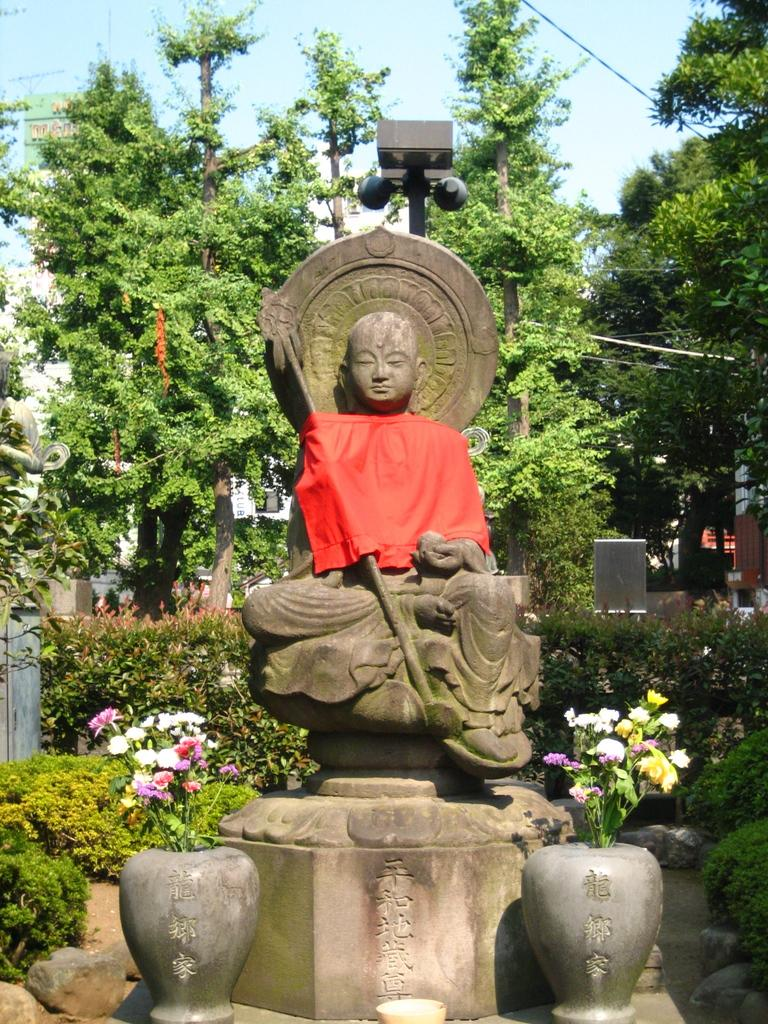What objects are in front of the statue in the image? There are flower vases in front of the statue in the image. What can be seen in the background of the image? There are plants and trees in the background of the image. What is visible at the top of the image? The sky is visible at the top of the image. Can you see the bird flying in the image? There is no bird visible in the image. What type of self-portrait is the statue holding in the image? The statue is not holding a self-portrait in the image, as there is no reference to a self-portrait or any other object being held by the statue. 